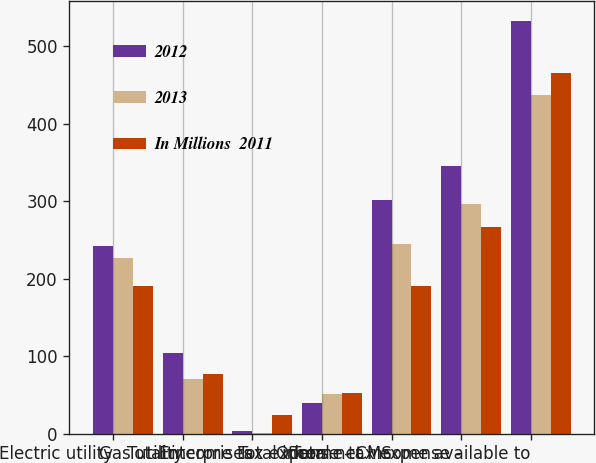Convert chart to OTSL. <chart><loc_0><loc_0><loc_500><loc_500><stacked_bar_chart><ecel><fcel>Electric utility<fcel>Gas utility<fcel>Enterprises<fcel>Other<fcel>Total income tax expense - CMS<fcel>Total income tax expense -<fcel>Total net income available to<nl><fcel>2012<fcel>242<fcel>104<fcel>4<fcel>40<fcel>302<fcel>346<fcel>532<nl><fcel>2013<fcel>227<fcel>70<fcel>1<fcel>51<fcel>245<fcel>297<fcel>437<nl><fcel>In Millions  2011<fcel>190<fcel>77<fcel>24<fcel>52<fcel>191<fcel>267<fcel>465<nl></chart> 